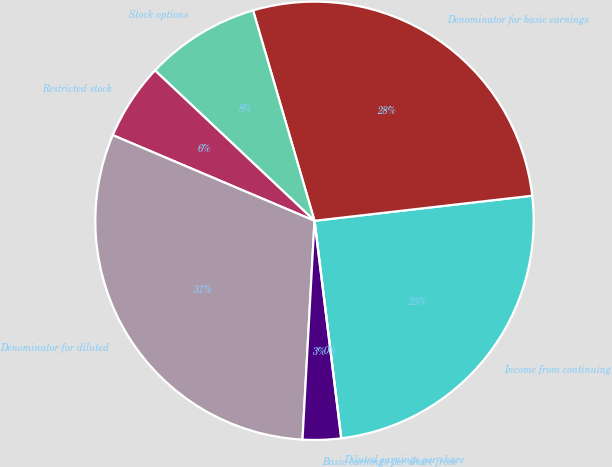Convert chart to OTSL. <chart><loc_0><loc_0><loc_500><loc_500><pie_chart><fcel>Income from continuing<fcel>Denominator for basic earnings<fcel>Stock options<fcel>Restricted stock<fcel>Denominator for diluted<fcel>Basic earnings per share from<fcel>Diluted earnings per share<nl><fcel>24.88%<fcel>27.7%<fcel>8.45%<fcel>5.64%<fcel>30.52%<fcel>2.82%<fcel>0.0%<nl></chart> 